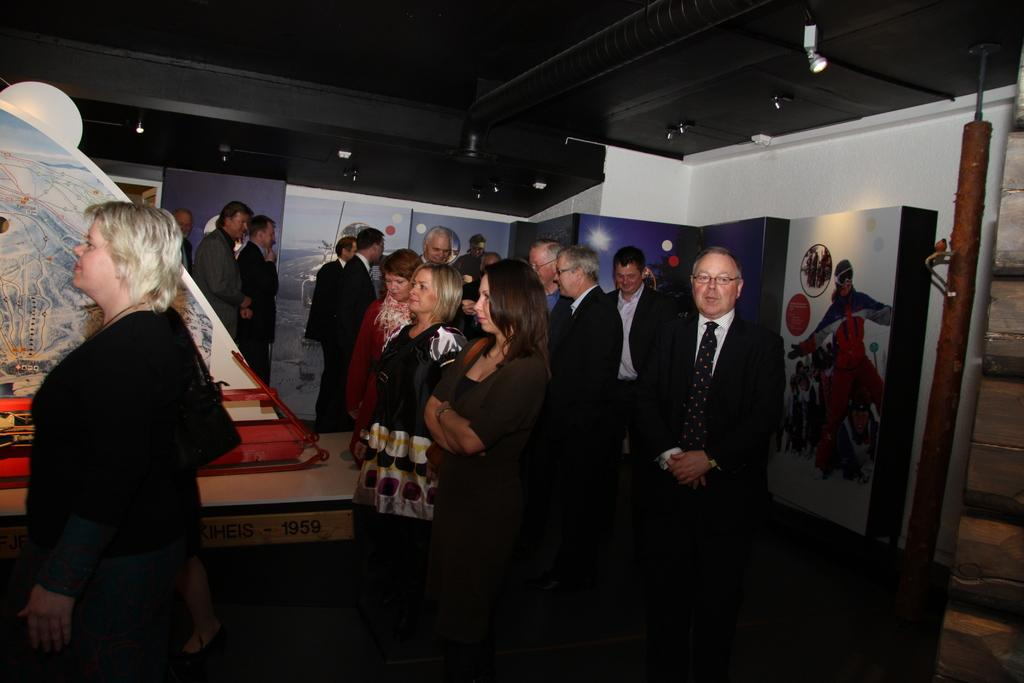What is happening in the middle of the image? There are people standing in the middle of the image. What are the people doing? The people are watching something. What is behind the people? There is a wall behind the people. What is on the wall? There are posters on the wall. What is visible at the top of the image? The top of the image contains a roof. What is the price of the news being discussed by the farmer in the image? There is no farmer or news present in the image; it features people watching something with a wall and posters behind them. 